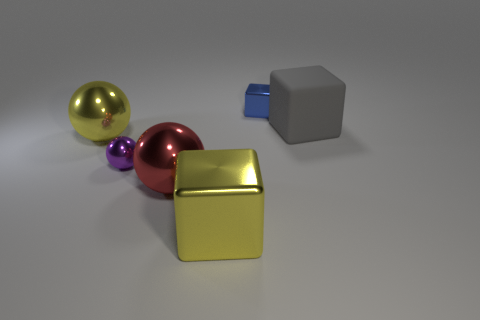Do the yellow cube and the red thing have the same material?
Offer a very short reply. Yes. How many other things are the same color as the small metallic cube?
Provide a short and direct response. 0. Is the number of rubber things greater than the number of big shiny things?
Give a very brief answer. No. There is a rubber object; is its size the same as the cube in front of the rubber thing?
Make the answer very short. Yes. There is a metal block that is behind the yellow metallic sphere; what color is it?
Ensure brevity in your answer.  Blue. What number of yellow things are either big shiny things or big objects?
Your answer should be compact. 2. What color is the tiny cube?
Provide a succinct answer. Blue. Is there anything else that has the same material as the large yellow cube?
Keep it short and to the point. Yes. Is the number of red objects that are behind the rubber object less than the number of large cubes that are left of the purple ball?
Your answer should be very brief. No. The shiny thing that is in front of the big gray matte object and behind the small metal ball has what shape?
Your answer should be compact. Sphere. 